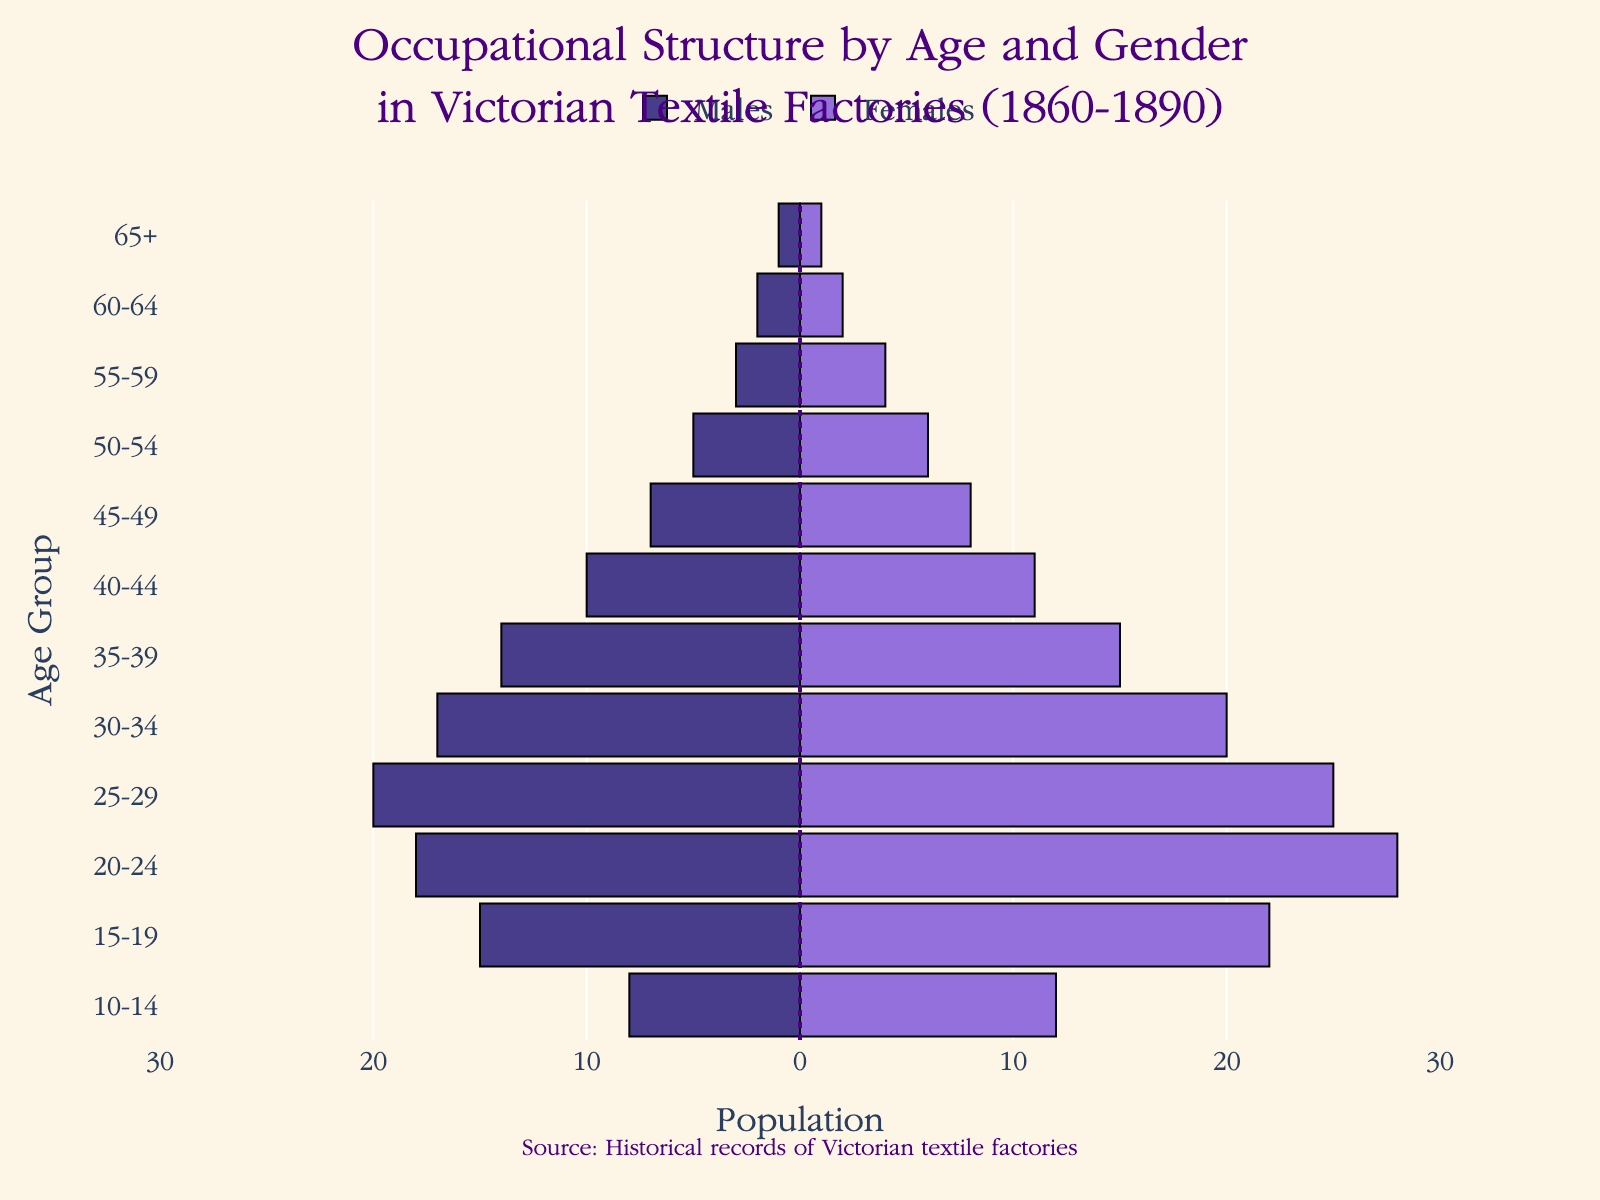What is the title of the figure? The title of the figure is located at the top and is typically the largest text. It reads: "Occupational Structure by Age and Gender in Victorian Textile Factories (1860-1890)"
Answer: Occupational Structure by Age and Gender in Victorian Textile Factories (1860-1890) What color represents females in the figure? By examining the bars on the right side of the pyramid, you can see they are shaded in a specific color. This color, which is on the legend and bars, is light purple.
Answer: Light purple What age group has the highest number of females working in Victorian textile factories? Look at the longest bar on the right side of the pyramid. The 20-24 age group has the longest bar, indicating the highest number of females.
Answer: 20-24 Which age group has the smallest total number of workers (males + females)? To find the smallest total number, add the male and female counts for each age group and compare. The smallest bar is for 65+, with only 1 male and 1 female.
Answer: 65+ How many males aged 25-29 were working in textile factories? Locate the bar representing the 25-29 age group on the left side of the pyramid. The length of the bar represents 20 males.
Answer: 20 Are there more females or males in the 30-34 age group? Compare the lengths of the bars for the 30-34 age group. The bar representing females is slightly longer than the bar representing males.
Answer: Females What is the difference in population between males and females in the 20-24 age group? Identify the number of males (18) and females (28) in the 20-24 age group. The difference is calculated by subtracting the smaller number from the larger one. The difference is 28 - 18.
Answer: 10 Which gender has more workers in the 40-44 age group? Look at the length of the bars for the 40-44 age group. The bar for females is slightly longer than the one for males.
Answer: Females How many workers are there in total in the 55-59 age group? Add the number of males (3) and females (4) in the 55-59 age group. The total is 3 + 4.
Answer: 7 What is the trend in the number of workers across age groups? Observe the lengths of the bars from youngest to oldest age groups. Generally, the bar lengths decrease as the age increases, showing fewer older workers in the industry.
Answer: Decreasing trend 